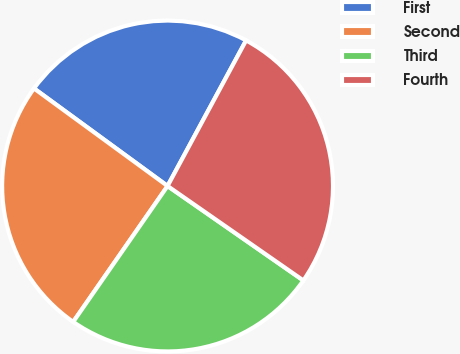Convert chart. <chart><loc_0><loc_0><loc_500><loc_500><pie_chart><fcel>First<fcel>Second<fcel>Third<fcel>Fourth<nl><fcel>22.83%<fcel>25.38%<fcel>24.99%<fcel>26.8%<nl></chart> 